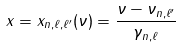Convert formula to latex. <formula><loc_0><loc_0><loc_500><loc_500>x = x _ { n , \ell , \ell ^ { \prime } } ( \nu ) = \frac { \nu - \nu _ { n , \ell ^ { \prime } } } { \gamma _ { n , \ell } }</formula> 